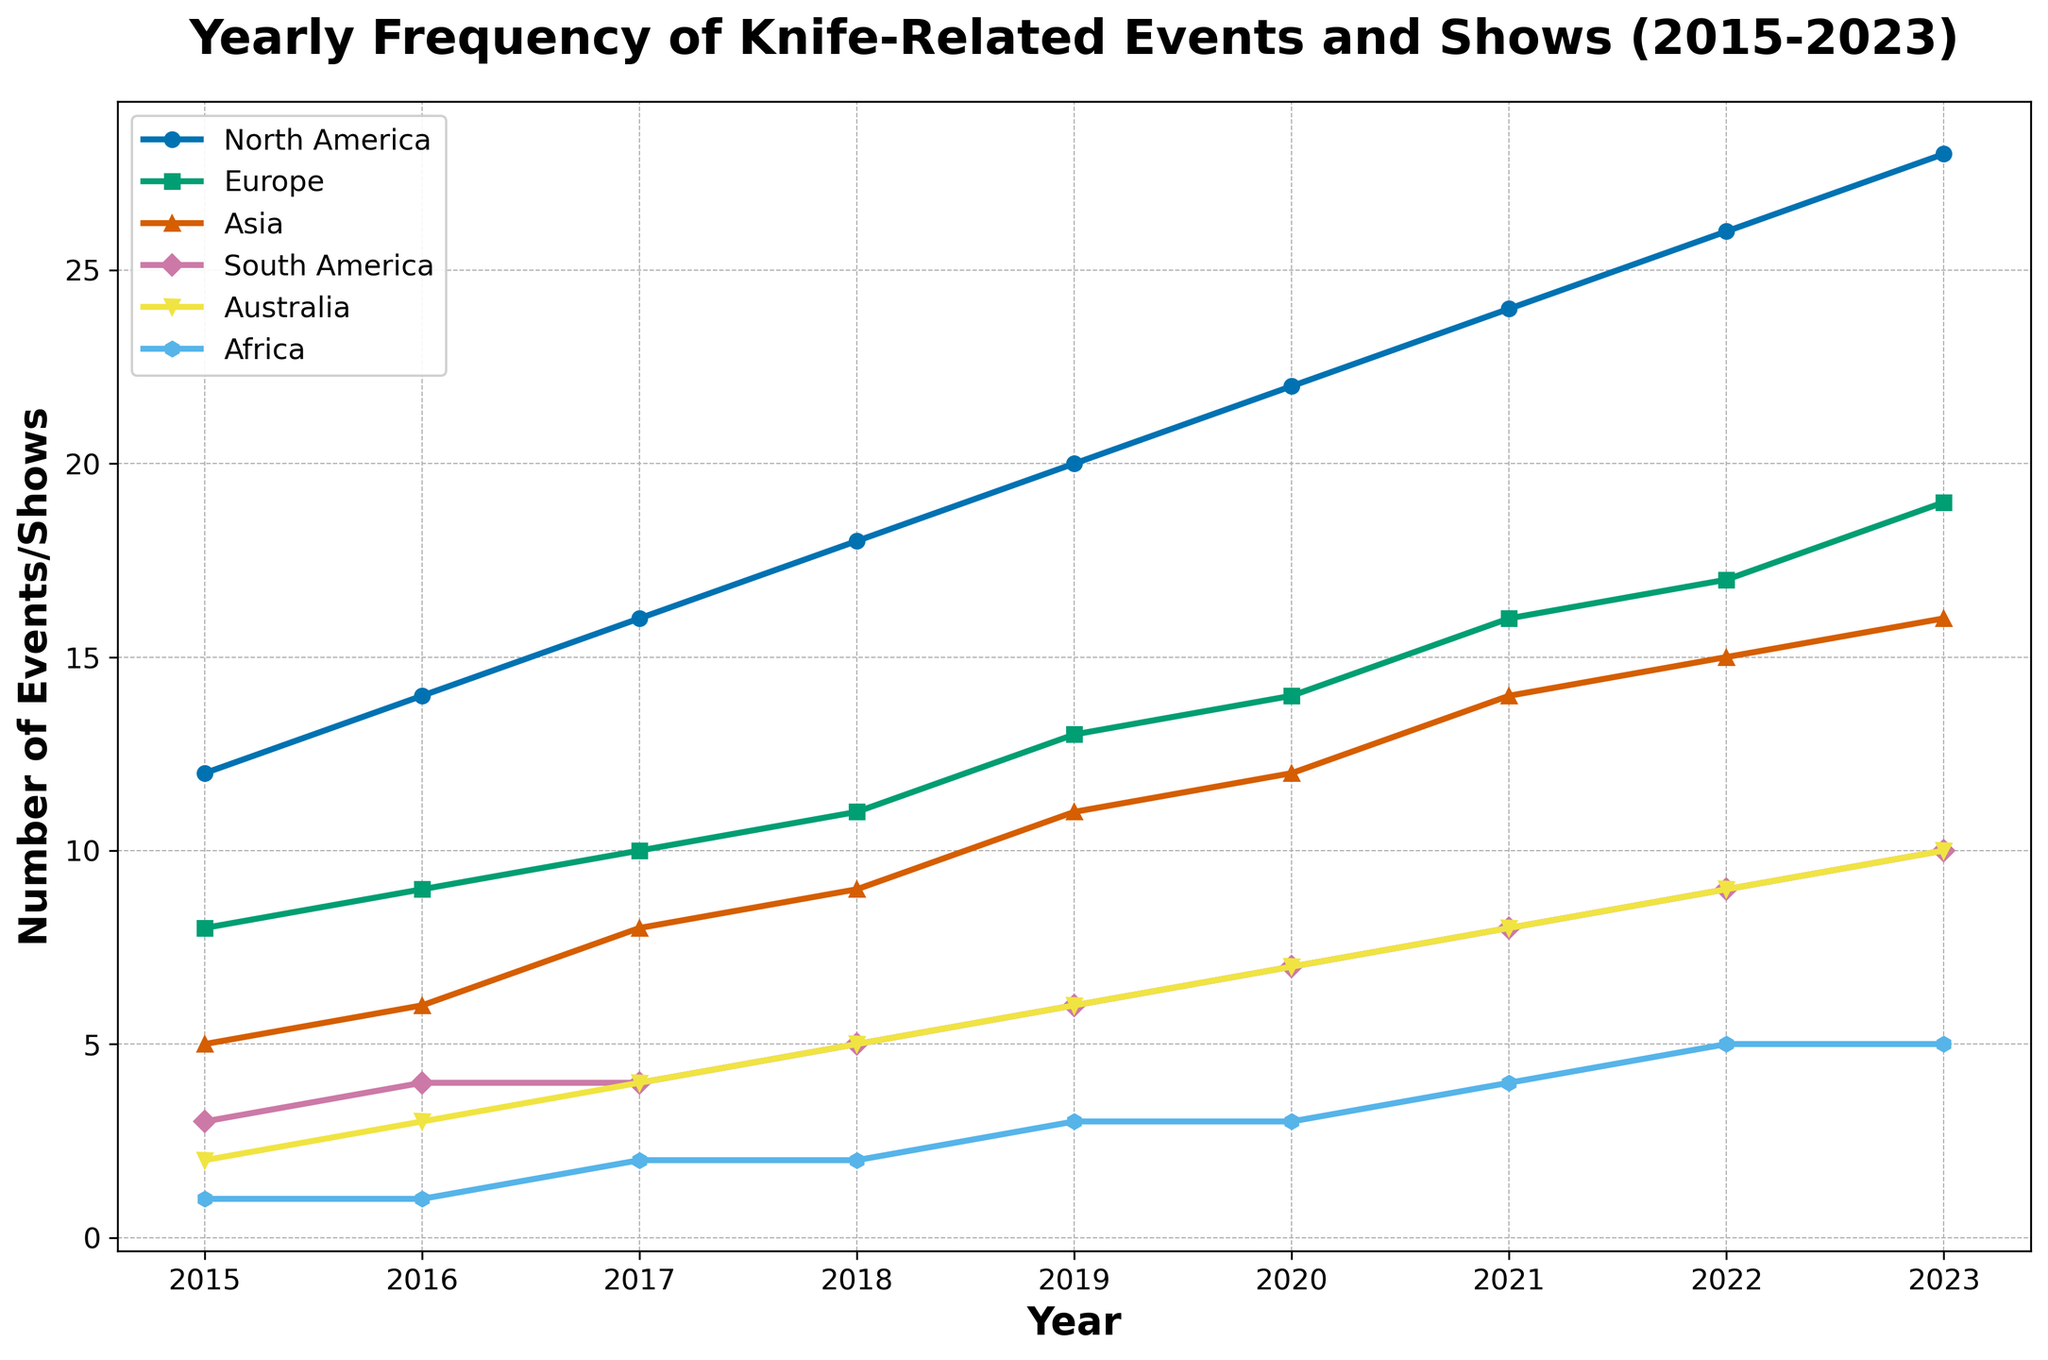Which region experienced the greatest increase in knife-related events from 2015 to 2023? By comparing the differences in the frequency from 2015 to 2023 for each region: North America (28-12=16), Europe (19-8=11), Asia (16-5=11), South America (10-3=7), Australia (10-2=8), Africa (5-1=4), it is clear that North America had the greatest increase of 16 events.
Answer: North America How many events were held in Asia and Australia combined in 2021? Add the 2021 values for Asia (14 events) and Australia (8 events): 14 + 8 = 22.
Answer: 22 Which year did Africa first reach 3 knife-related events? Observing the data for Africa, 3 events were first recorded in 2019.
Answer: 2019 What is the average number of events held in Europe from 2015 to 2023? Sum the yearly events for Europe from 2015 to 2023 (8, 9, 10, 11, 13, 14, 16, 17, 19) which equals 117, then divide by the number of years which is 9. The average = 117 / 9 ≈ 13 events.
Answer: 13 In which year did South America have more events than Africa for the first time? Observing the values for South America (3, 4, 4, 5, 6, 7, 8, 9, 10) and Africa (1, 1, 2, 2, 3, 3, 4, 5, 5), in 2018 they both had 3 events. By 2019, South America had 4 events, surpassing Africa with 3 events.
Answer: 2019 Which region had the smallest total number of knife-related events from 2015 to 2023? Add the total events from 2015 to 2023 for each region: North America (156), Europe (117), Asia (96), South America (56), Australia (54), Africa (26). Africa has the smallest total of 26 events.
Answer: Africa What was the percentage increase in knife-related events in Europe from 2015 to 2023? The number of events in Europe increased from 8 in 2015 to 19 in 2023. Percentage increase = ((19 - 8) / 8) * 100 = (11 / 8) * 100 = 137.5%.
Answer: 137.5% Which regions have consistently increased the number of knife-related events each year from 2015 to 2023? Observing the data, all regions (North America, Europe, Asia, South America, Australia, Africa) have a consistent year-on-year increase in the number of events over the given period.
Answer: All regions Which two regions had the same number of events in 2023? Looking at the 2023 values, Asia and South America each had 16 events in 2023.
Answer: Asia and South America 